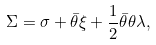<formula> <loc_0><loc_0><loc_500><loc_500>\Sigma = \sigma + \bar { \theta } \xi + \frac { 1 } { 2 } \bar { \theta } \theta \lambda ,</formula> 